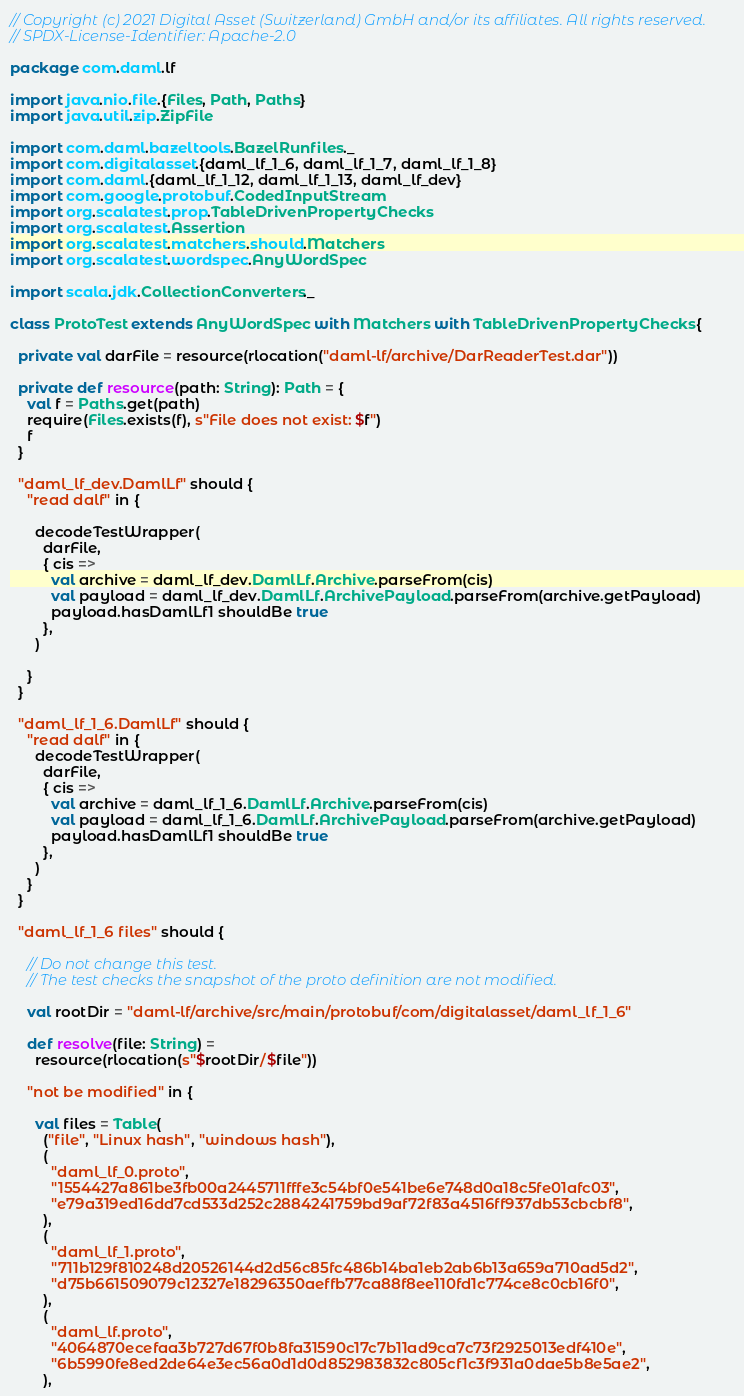<code> <loc_0><loc_0><loc_500><loc_500><_Scala_>// Copyright (c) 2021 Digital Asset (Switzerland) GmbH and/or its affiliates. All rights reserved.
// SPDX-License-Identifier: Apache-2.0

package com.daml.lf

import java.nio.file.{Files, Path, Paths}
import java.util.zip.ZipFile

import com.daml.bazeltools.BazelRunfiles._
import com.digitalasset.{daml_lf_1_6, daml_lf_1_7, daml_lf_1_8}
import com.daml.{daml_lf_1_12, daml_lf_1_13, daml_lf_dev}
import com.google.protobuf.CodedInputStream
import org.scalatest.prop.TableDrivenPropertyChecks
import org.scalatest.Assertion
import org.scalatest.matchers.should.Matchers
import org.scalatest.wordspec.AnyWordSpec

import scala.jdk.CollectionConverters._

class ProtoTest extends AnyWordSpec with Matchers with TableDrivenPropertyChecks {

  private val darFile = resource(rlocation("daml-lf/archive/DarReaderTest.dar"))

  private def resource(path: String): Path = {
    val f = Paths.get(path)
    require(Files.exists(f), s"File does not exist: $f")
    f
  }

  "daml_lf_dev.DamlLf" should {
    "read dalf" in {

      decodeTestWrapper(
        darFile,
        { cis =>
          val archive = daml_lf_dev.DamlLf.Archive.parseFrom(cis)
          val payload = daml_lf_dev.DamlLf.ArchivePayload.parseFrom(archive.getPayload)
          payload.hasDamlLf1 shouldBe true
        },
      )

    }
  }

  "daml_lf_1_6.DamlLf" should {
    "read dalf" in {
      decodeTestWrapper(
        darFile,
        { cis =>
          val archive = daml_lf_1_6.DamlLf.Archive.parseFrom(cis)
          val payload = daml_lf_1_6.DamlLf.ArchivePayload.parseFrom(archive.getPayload)
          payload.hasDamlLf1 shouldBe true
        },
      )
    }
  }

  "daml_lf_1_6 files" should {

    // Do not change this test.
    // The test checks the snapshot of the proto definition are not modified.

    val rootDir = "daml-lf/archive/src/main/protobuf/com/digitalasset/daml_lf_1_6"

    def resolve(file: String) =
      resource(rlocation(s"$rootDir/$file"))

    "not be modified" in {

      val files = Table(
        ("file", "Linux hash", "windows hash"),
        (
          "daml_lf_0.proto",
          "1554427a861be3fb00a2445711fffe3c54bf0e541be6e748d0a18c5fe01afc03",
          "e79a319ed16dd7cd533d252c2884241759bd9af72f83a4516ff937db53cbcbf8",
        ),
        (
          "daml_lf_1.proto",
          "711b129f810248d20526144d2d56c85fc486b14ba1eb2ab6b13a659a710ad5d2",
          "d75b661509079c12327e18296350aeffb77ca88f8ee110fd1c774ce8c0cb16f0",
        ),
        (
          "daml_lf.proto",
          "4064870ecefaa3b727d67f0b8fa31590c17c7b11ad9ca7c73f2925013edf410e",
          "6b5990fe8ed2de64e3ec56a0d1d0d852983832c805cf1c3f931a0dae5b8e5ae2",
        ),</code> 